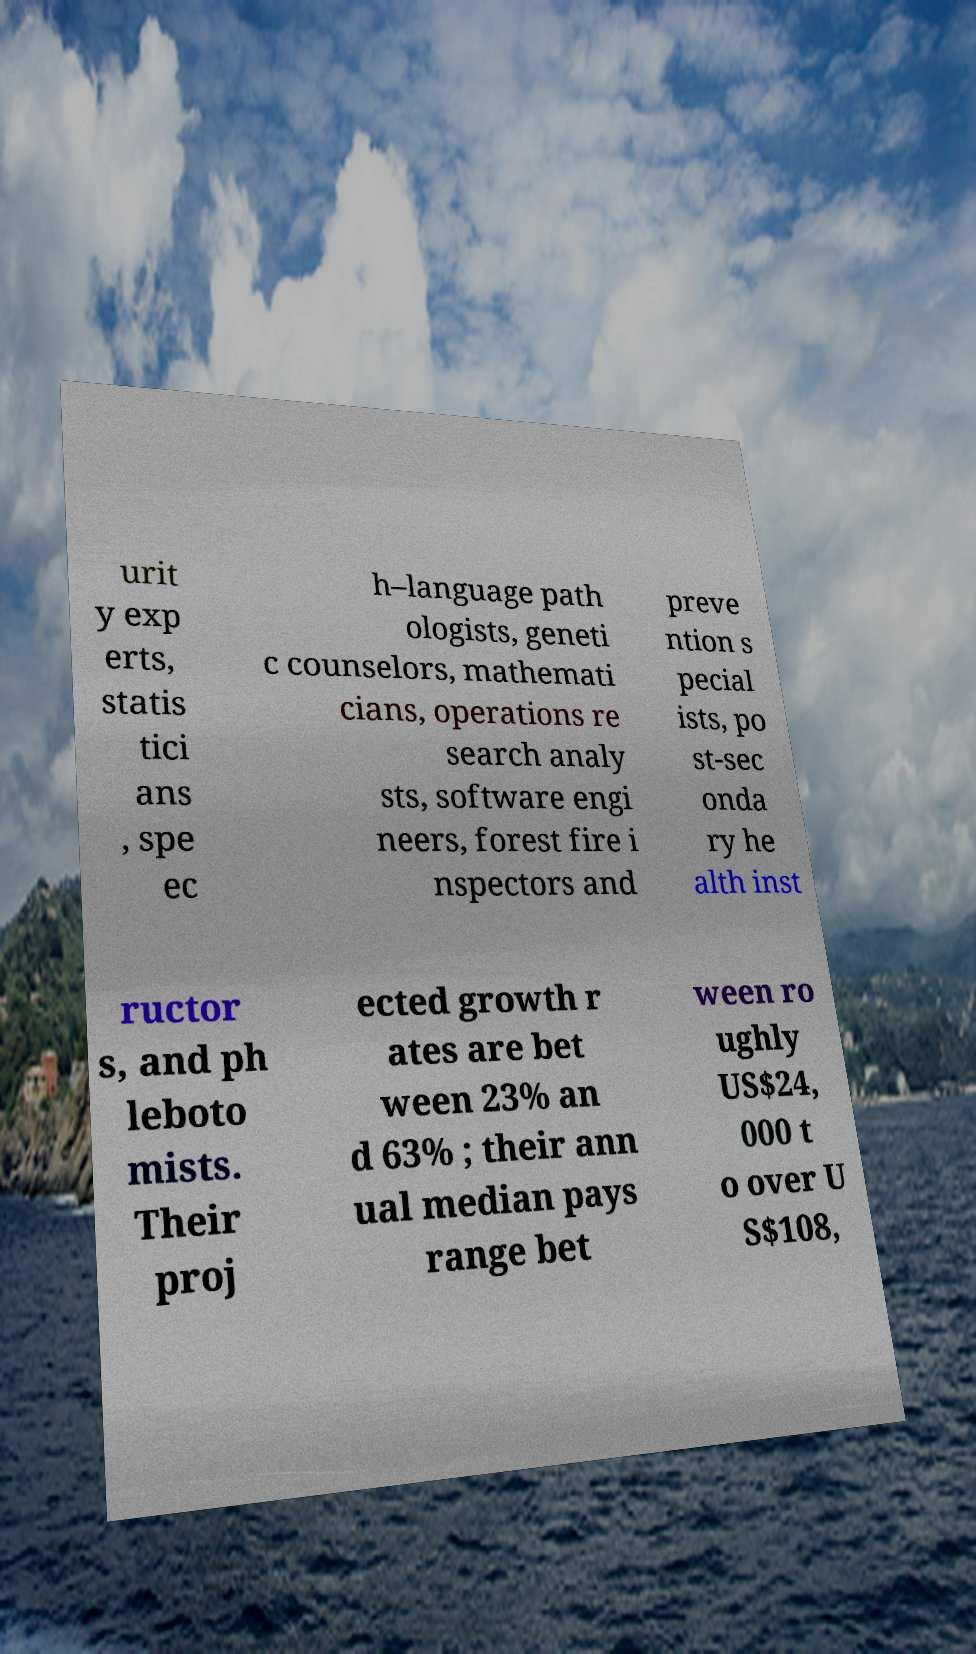Please read and relay the text visible in this image. What does it say? urit y exp erts, statis tici ans , spe ec h–language path ologists, geneti c counselors, mathemati cians, operations re search analy sts, software engi neers, forest fire i nspectors and preve ntion s pecial ists, po st-sec onda ry he alth inst ructor s, and ph leboto mists. Their proj ected growth r ates are bet ween 23% an d 63% ; their ann ual median pays range bet ween ro ughly US$24, 000 t o over U S$108, 